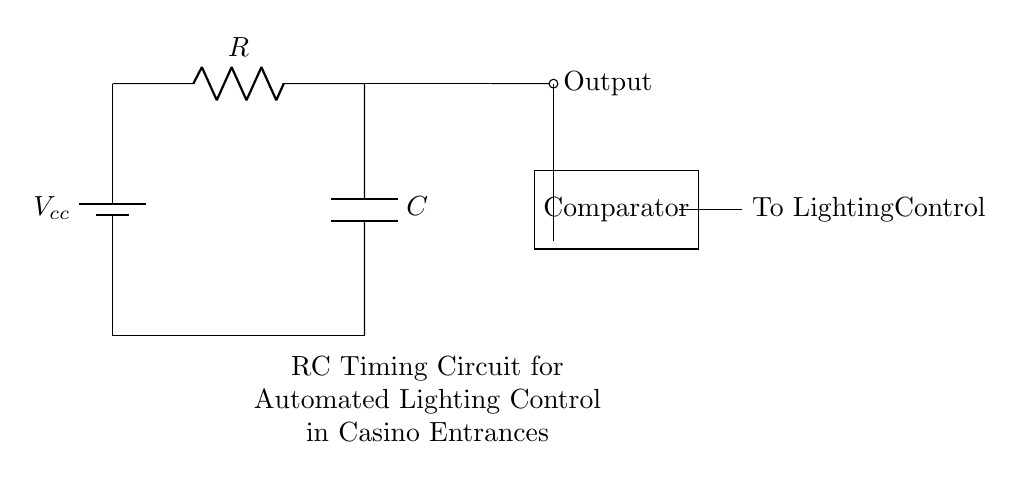What is the value of the resistor in this circuit? The circuit diagram labels the resistor as R, but does not specify an exact value. Therefore, we typically denote it simply as R.
Answer: R What component is used to store energy in this circuit? The component used to store energy in the circuit is indicated as C, which represents a capacitor. Capacitors are known for their ability to store charge, and thus energy, in an electric field.
Answer: Capacitor What type of circuit is this? The circuit diagram depicts an RC timing circuit which consists of a resistor and a capacitor used for timing purposes. This specific arrangement can control the delay in signal output, ideal for functions like automated lighting.
Answer: RC timing circuit What happens when the voltage reaches the comparator threshold? When the voltage across the capacitor reaches the threshold voltage set in the comparator, the comparator switches its output to activate the lighting control mechanism. This allows the lights to turn on after a specific timing delay, controlled by the values of the resistor and capacitor.
Answer: Lighting activates What is the role of the comparator in this circuit? The comparator compares the voltage across the capacitor to a reference voltage. When the voltage exceeds this reference, the comparator triggers an output, signaling the lighting control to turn on the lights. This is important for determining when the voltage is sufficient to activate the lights, ensuring proper timing for casino entrances.
Answer: Control activation What determines the timing interval in this RC circuit? The timing interval in an RC circuit is determined by the values of the resistor and capacitor. The time constant, which defines how quickly the capacitor charges and discharges, is calculated using the formula τ = R × C, where τ is the time constant. A higher resistance or capacitance results in a longer timing interval.
Answer: Resistance and capacitance 